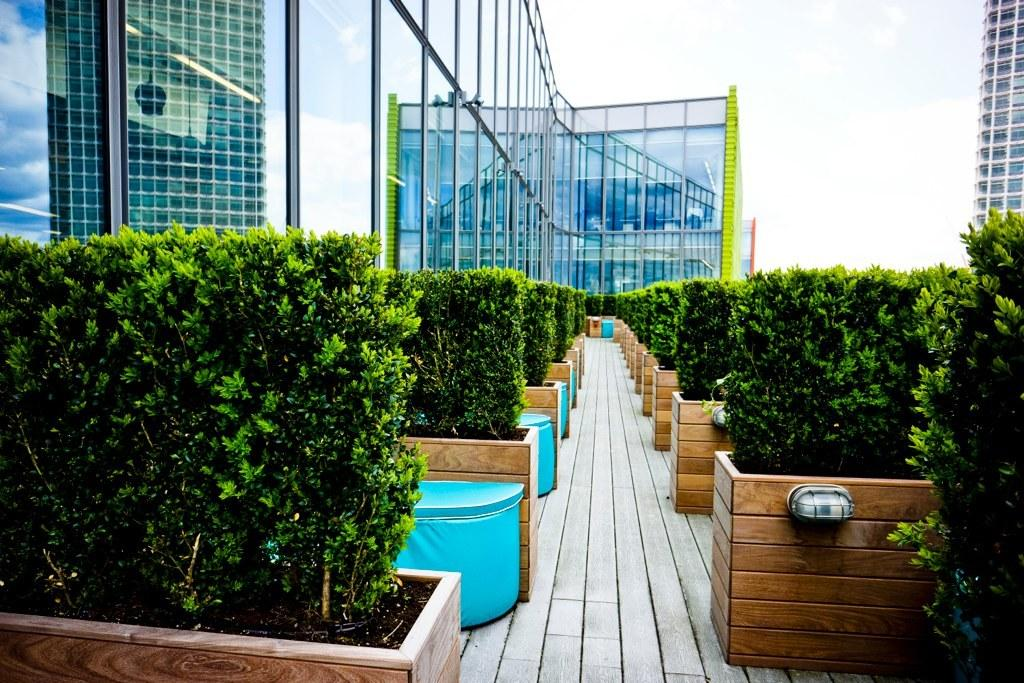What type of containers are the plants in the image placed? The plants in the image are placed in wooden boxes. What else can be seen in the image besides the plants? Buildings are visible in the image. What is the surface of the glass in the image reflecting? There are reflections on the glass in the image. What is visible at the top of the image? The sky is visible at the top of the image. What question is being asked by the tree in the image? There are no trees present in the image, and trees cannot ask questions. 